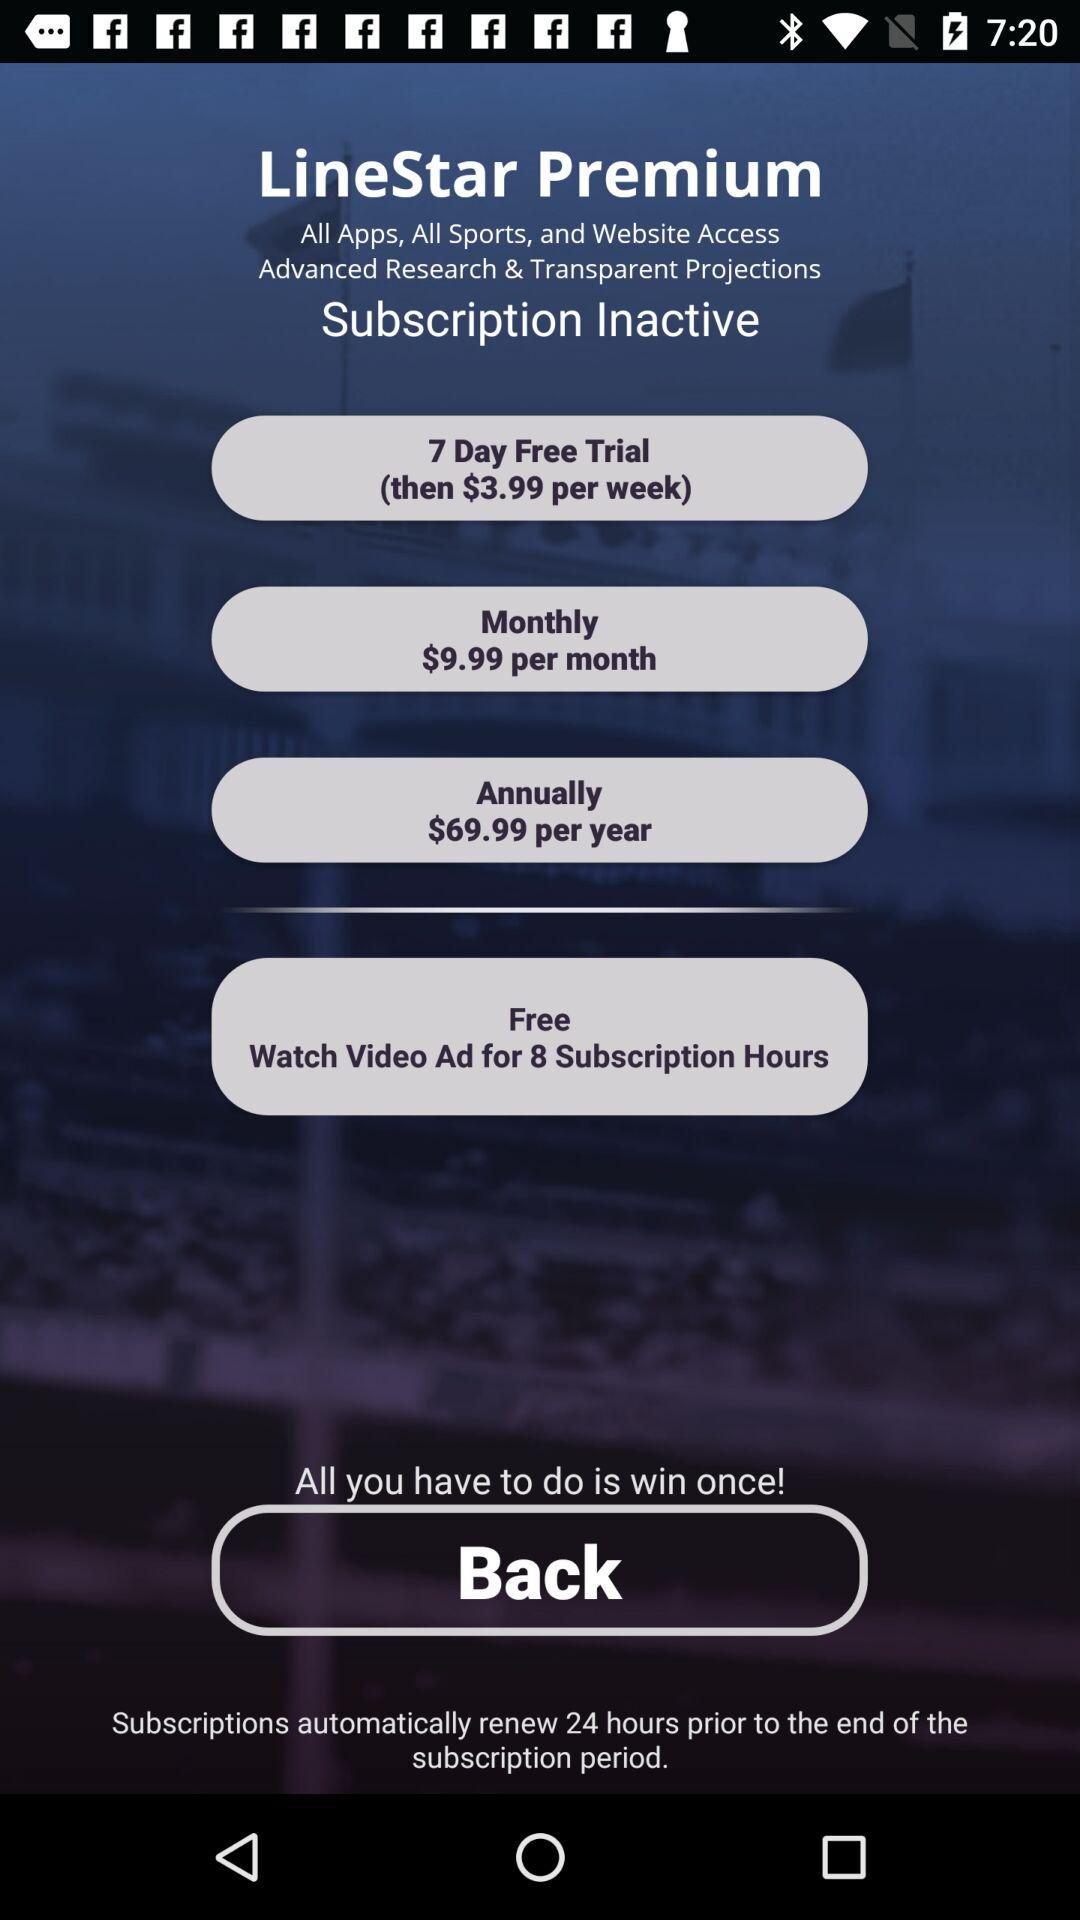What’s the currency for the prices? The currency is $. 